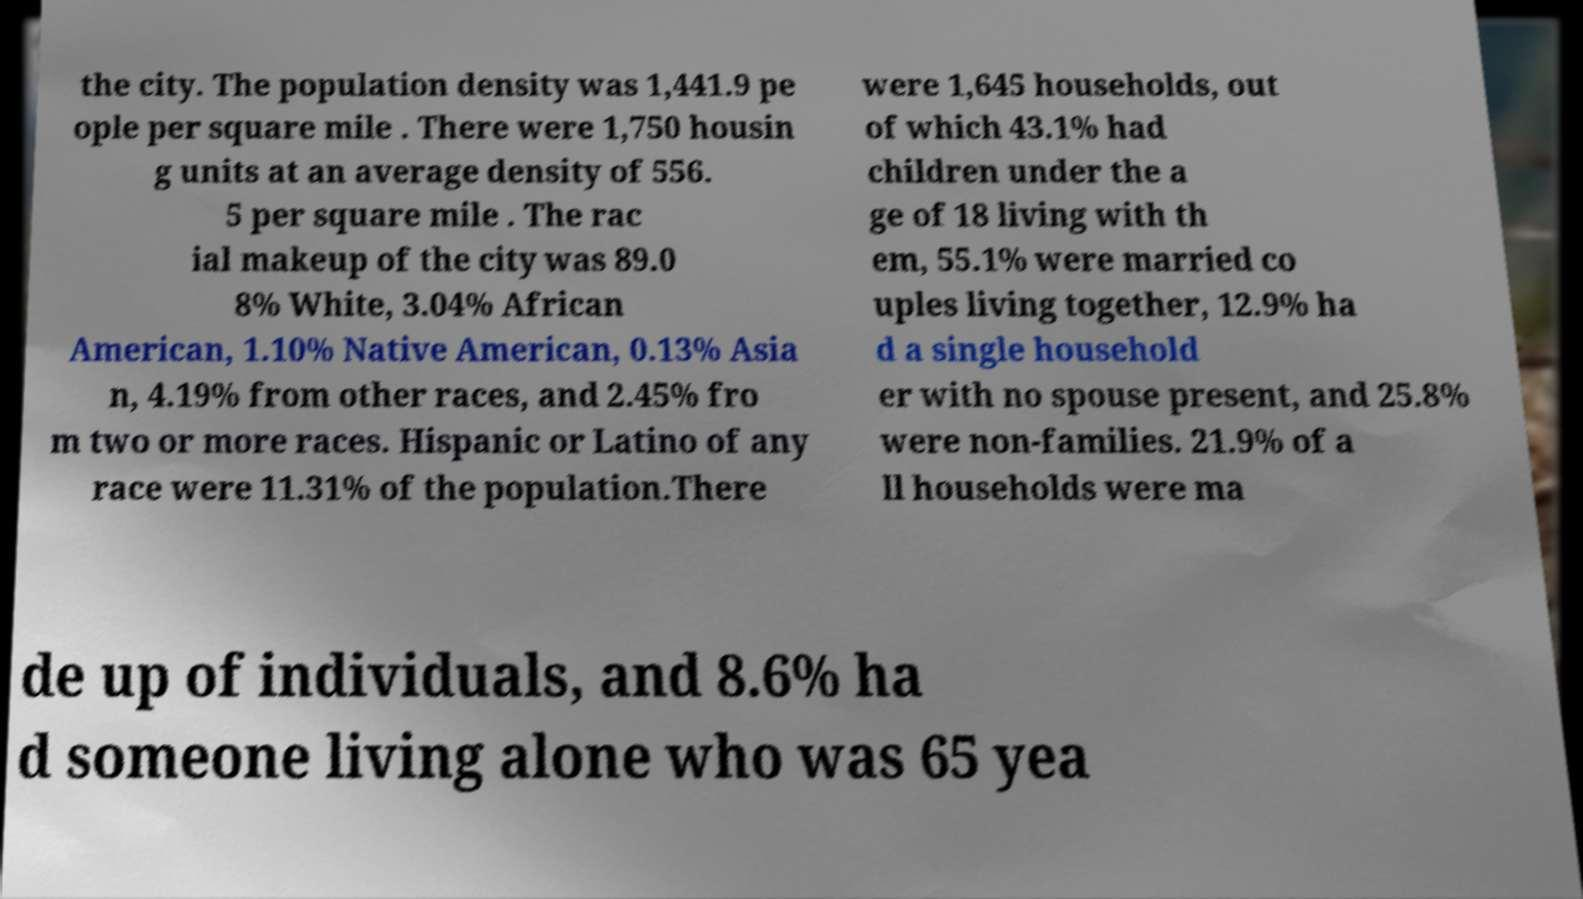Can you read and provide the text displayed in the image?This photo seems to have some interesting text. Can you extract and type it out for me? the city. The population density was 1,441.9 pe ople per square mile . There were 1,750 housin g units at an average density of 556. 5 per square mile . The rac ial makeup of the city was 89.0 8% White, 3.04% African American, 1.10% Native American, 0.13% Asia n, 4.19% from other races, and 2.45% fro m two or more races. Hispanic or Latino of any race were 11.31% of the population.There were 1,645 households, out of which 43.1% had children under the a ge of 18 living with th em, 55.1% were married co uples living together, 12.9% ha d a single household er with no spouse present, and 25.8% were non-families. 21.9% of a ll households were ma de up of individuals, and 8.6% ha d someone living alone who was 65 yea 